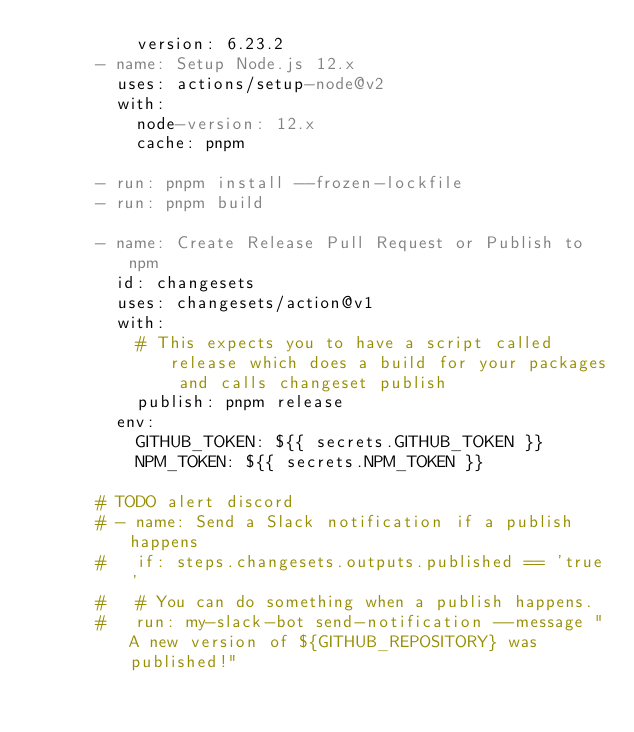Convert code to text. <code><loc_0><loc_0><loc_500><loc_500><_YAML_>          version: 6.23.2
      - name: Setup Node.js 12.x
        uses: actions/setup-node@v2
        with:
          node-version: 12.x
          cache: pnpm

      - run: pnpm install --frozen-lockfile
      - run: pnpm build

      - name: Create Release Pull Request or Publish to npm
        id: changesets
        uses: changesets/action@v1
        with:
          # This expects you to have a script called release which does a build for your packages and calls changeset publish
          publish: pnpm release
        env:
          GITHUB_TOKEN: ${{ secrets.GITHUB_TOKEN }}
          NPM_TOKEN: ${{ secrets.NPM_TOKEN }}

      # TODO alert discord
      # - name: Send a Slack notification if a publish happens
      #   if: steps.changesets.outputs.published == 'true'
      #   # You can do something when a publish happens.
      #   run: my-slack-bot send-notification --message "A new version of ${GITHUB_REPOSITORY} was published!"
</code> 